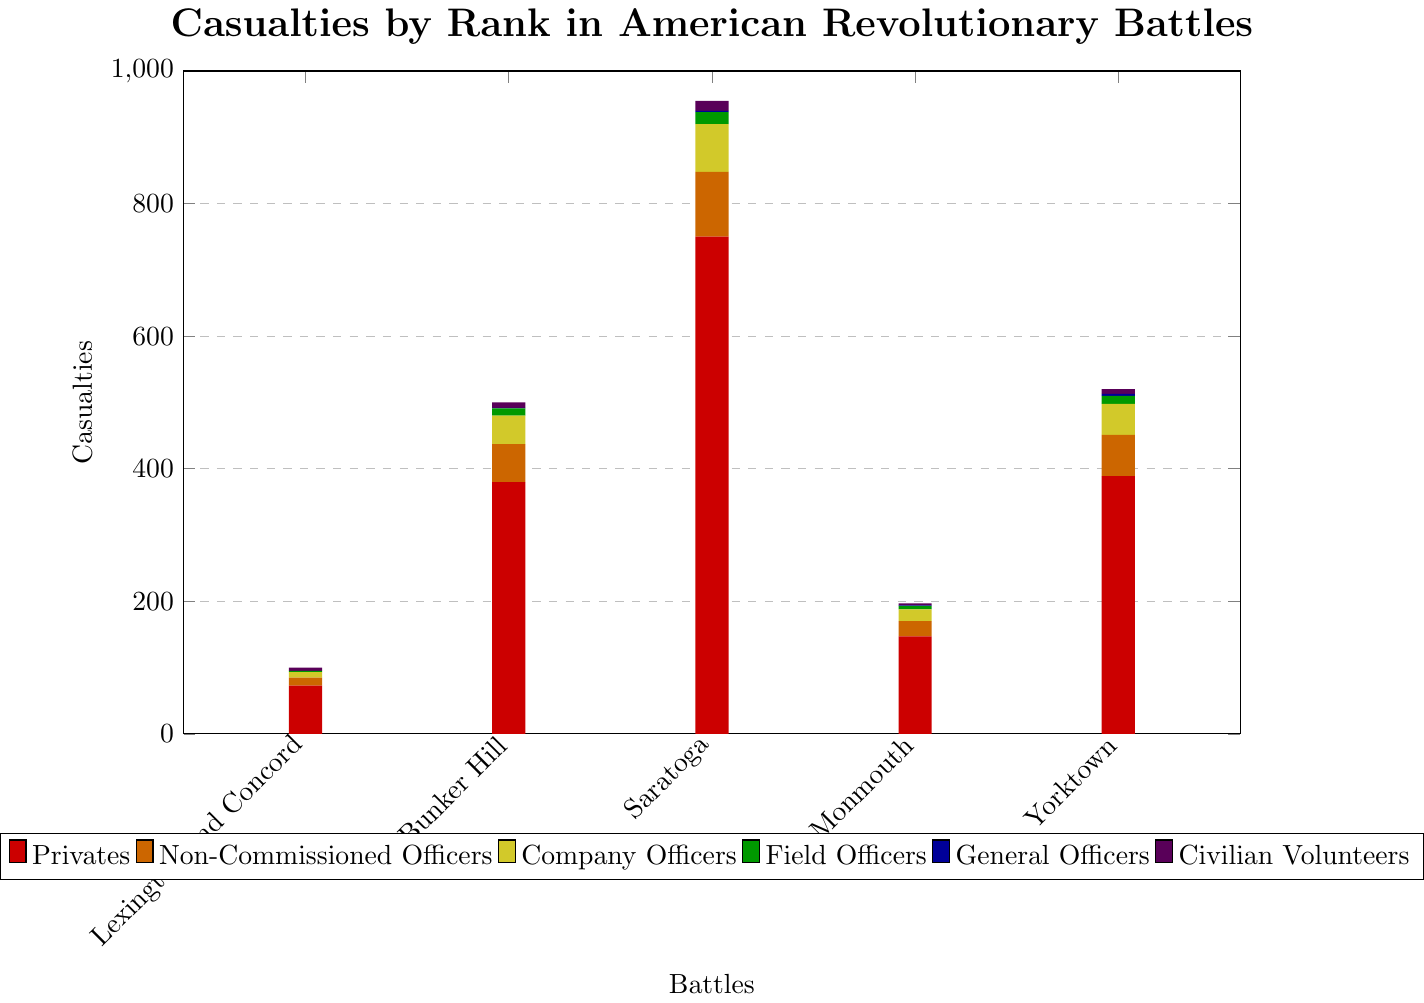Which battle had the highest number of casualties among Privates? To determine this, look at the height of the red bars, which represent Privates' casualties, and find the tallest one. For Saratoga, it is 750.
Answer: Saratoga Among Non-Commissioned Officers, in which two battles were the casualties the least? Identify the bars representing Non-Commissioned Officers' casualties (orange bars) and find the lowest values. The lowest values are 12 for Lexington and Concord and 23 for Monmouth.
Answer: Lexington and Concord, Monmouth Which battle had more Field Officer casualties: Monmouth or Bunker Hill? Compare the green bars for Monmouth (5) and Bunker Hill (11) to see which one is higher.
Answer: Bunker Hill How many total casualties were reported in Yorktown? Sum the heights of all bars at the Yorktown spot: 389 (Privates) + 62 (Non-Commissioned Officers) + 47 (Company Officers) + 12 (Field Officers) + 3 (General Officers) + 7 (Civilian Volunteers) = 520
Answer: 520 Compare the total number of casualties for Civilian Volunteers in all battles. Which battle had the fewest? Add up the bars for Civilian Volunteers (purple bars): 5 (Lexington and Concord), 8 (Bunker Hill), 15 (Saratoga), 3 (Monmouth), and 7 (Yorktown). The fewest casualties are at Monmouth with 3.
Answer: Monmouth Which category of soldiers had no casualties in Lexington and Concord? Look at the absence of a specific colored bar at the Lexington and Concord spot. No blue bar (General Officers) is present there.
Answer: General Officers What is the ratio of casualties between Company Officers and Field Officers in Bunker Hill? Find the bars representing Company Officers (yellow, 43) and Field Officers (green, 11) in Bunker Hill, then divide 43 by 11 to get the ratio 43:11.
Answer: 43:11 Determine the average number of casualties for Non-Commissioned Officers across all battles. Sum the values (12 + 57 + 98 + 23 + 62 = 252) and then divide by the number of battles (5). 252 / 5 = 50.4
Answer: 50.4 In which battles were there more than 50 casualties among Company Officers? Identify the yellow bars representing Company Officers and check if they exceed 50. Saratoga (72) and Bunker Hill (43) have more than 50 casualties.
Answer: Saratoga 